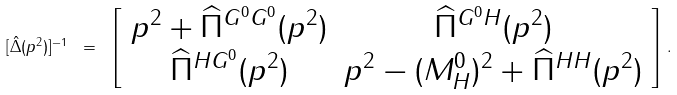Convert formula to latex. <formula><loc_0><loc_0><loc_500><loc_500>[ \hat { \Delta } ( p ^ { 2 } ) ] ^ { - 1 } \ = \ \left [ \begin{array} { c c } p ^ { 2 } + \widehat { \Pi } ^ { G ^ { 0 } G ^ { 0 } } ( p ^ { 2 } ) & \widehat { \Pi } ^ { G ^ { 0 } H } ( p ^ { 2 } ) \\ \widehat { \Pi } ^ { H G ^ { 0 } } ( p ^ { 2 } ) & p ^ { 2 } - ( M ^ { 0 } _ { H } ) ^ { 2 } + \widehat { \Pi } ^ { H H } ( p ^ { 2 } ) \end{array} \right ] \, .</formula> 